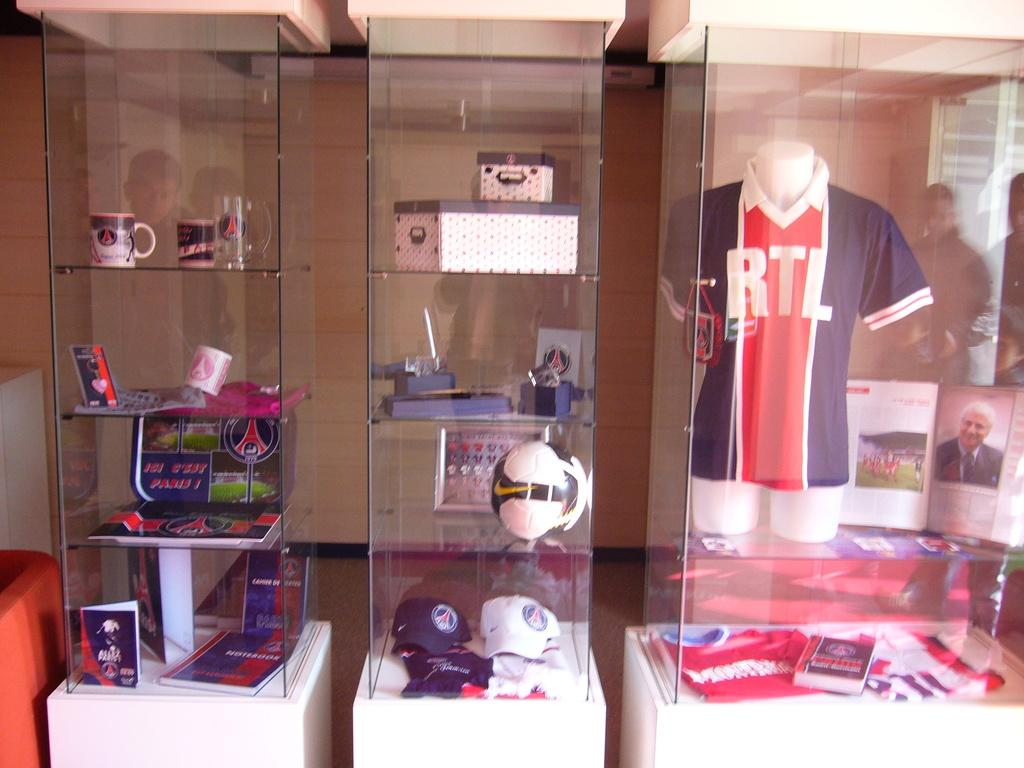Provide a one-sentence caption for the provided image. RTL Logo on a jersey in a glass window. 